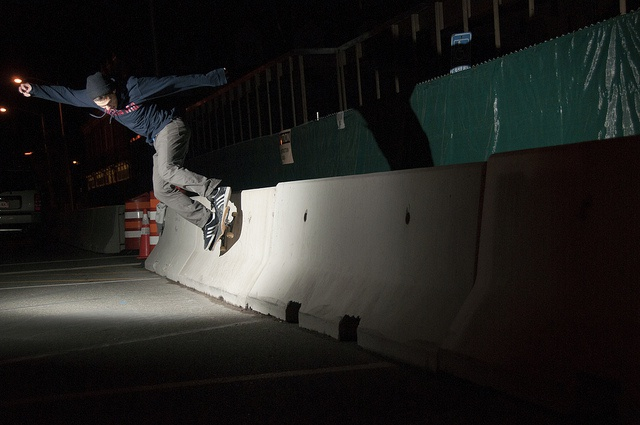Describe the objects in this image and their specific colors. I can see people in black, gray, and darkgray tones, car in black and gray tones, and skateboard in black, gray, lightgray, and tan tones in this image. 